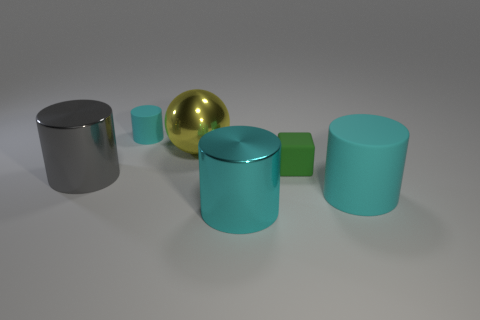Is there any other thing that has the same shape as the green rubber object?
Offer a very short reply. No. What number of rubber objects are there?
Provide a short and direct response. 3. What is the shape of the cyan rubber object that is on the right side of the tiny cyan matte thing?
Offer a very short reply. Cylinder. There is a large matte thing that is behind the big metallic cylinder that is to the right of the thing behind the shiny sphere; what color is it?
Offer a terse response. Cyan. There is a large cyan thing that is made of the same material as the large gray cylinder; what shape is it?
Give a very brief answer. Cylinder. Is the number of gray things less than the number of big yellow metallic cylinders?
Make the answer very short. No. Are the green object and the yellow thing made of the same material?
Offer a terse response. No. How many other things are the same color as the tiny matte cube?
Give a very brief answer. 0. Is the number of large things greater than the number of big gray cylinders?
Make the answer very short. Yes. There is a cyan shiny object; is its size the same as the metallic cylinder that is to the left of the cyan shiny cylinder?
Your answer should be very brief. Yes. 